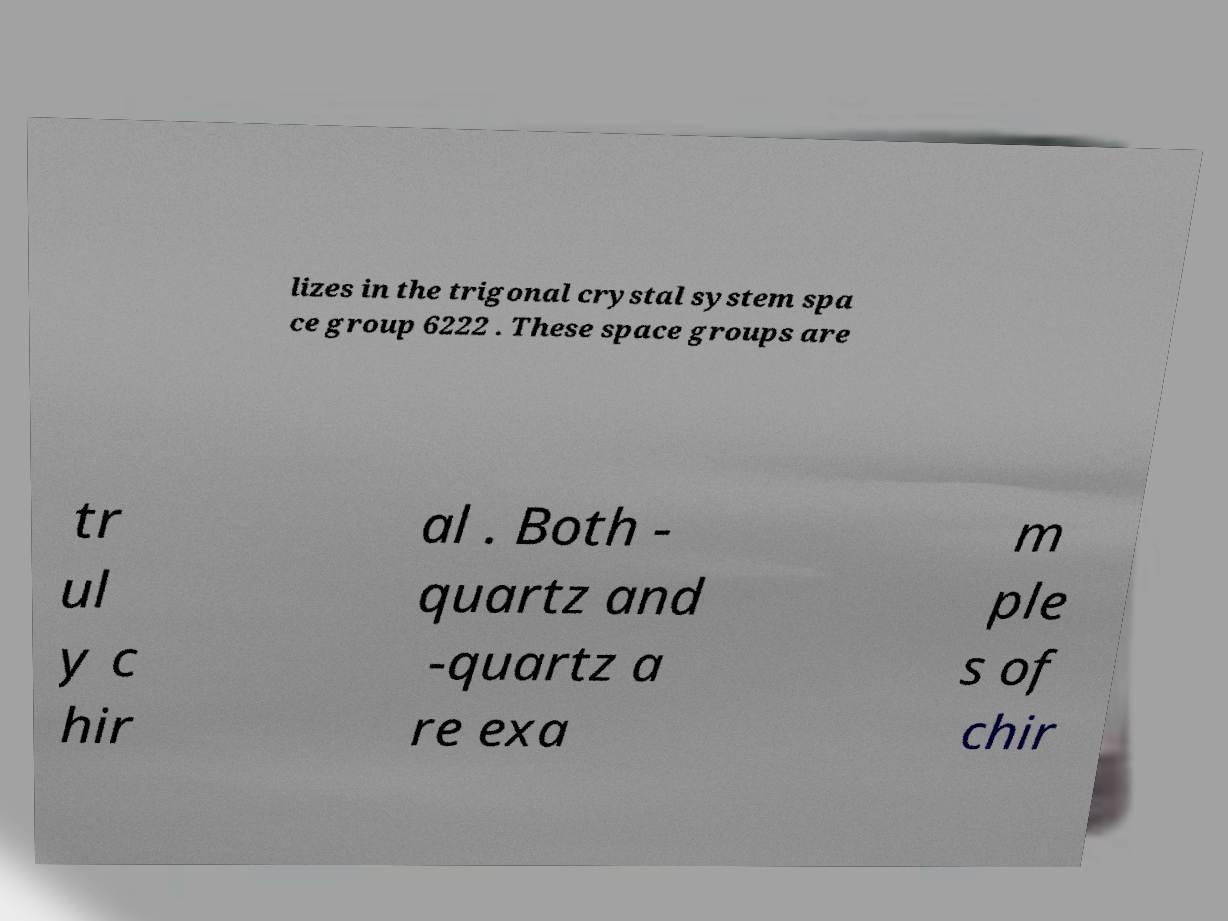Can you read and provide the text displayed in the image?This photo seems to have some interesting text. Can you extract and type it out for me? lizes in the trigonal crystal system spa ce group 6222 . These space groups are tr ul y c hir al . Both - quartz and -quartz a re exa m ple s of chir 